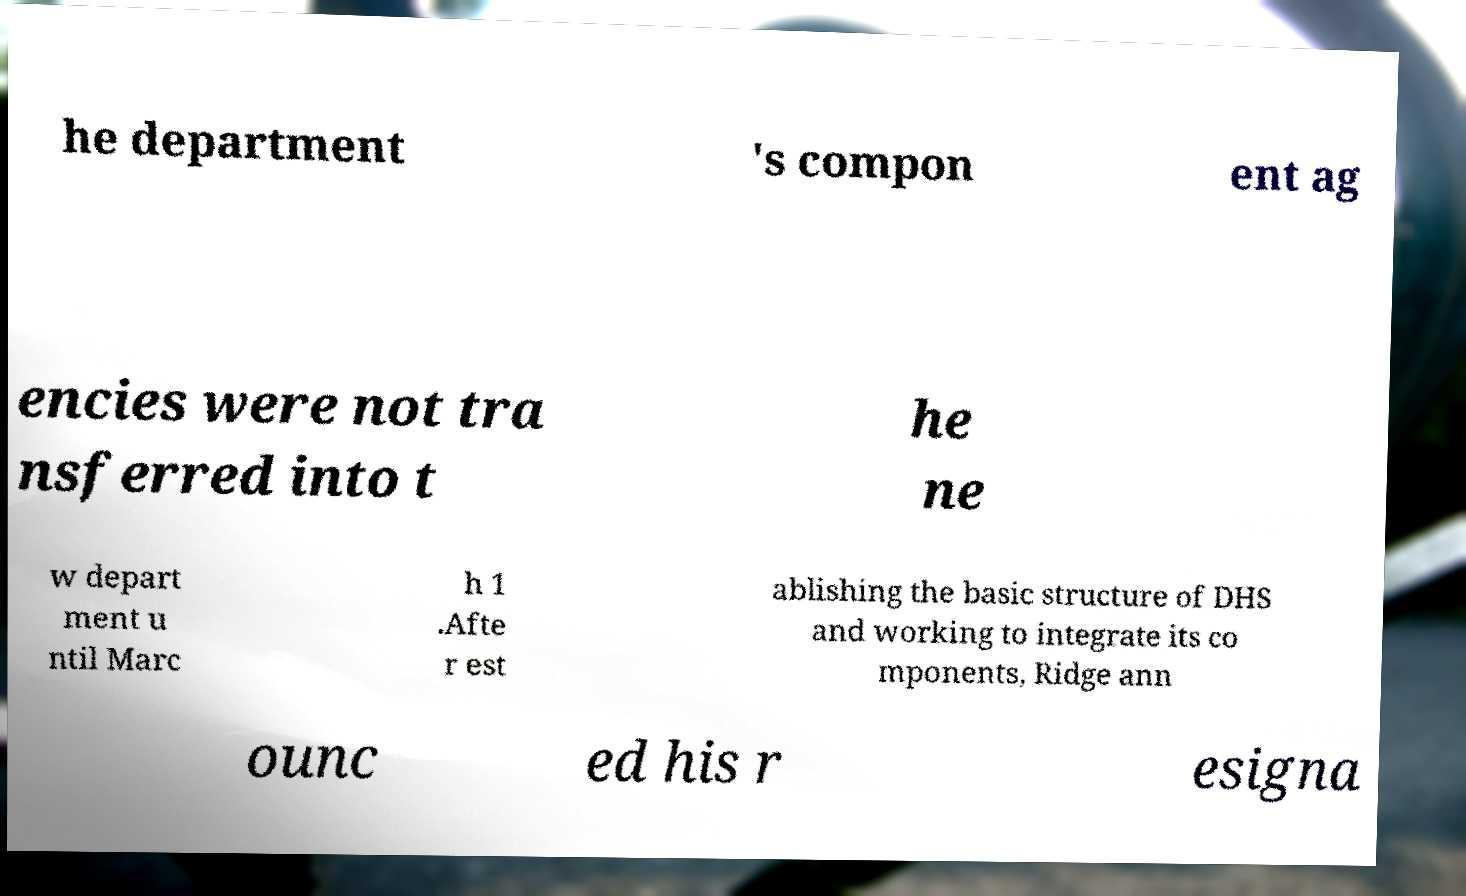Could you extract and type out the text from this image? he department 's compon ent ag encies were not tra nsferred into t he ne w depart ment u ntil Marc h 1 .Afte r est ablishing the basic structure of DHS and working to integrate its co mponents, Ridge ann ounc ed his r esigna 